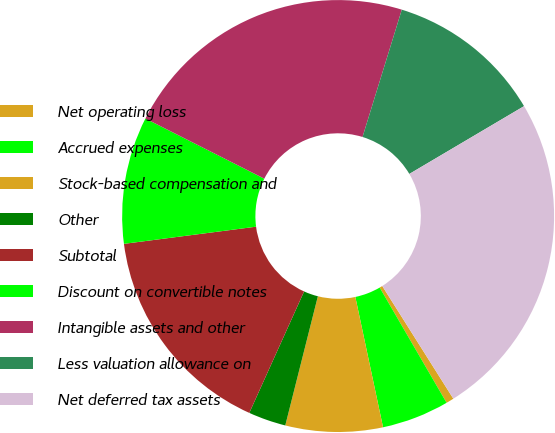Convert chart to OTSL. <chart><loc_0><loc_0><loc_500><loc_500><pie_chart><fcel>Net operating loss<fcel>Accrued expenses<fcel>Stock-based compensation and<fcel>Other<fcel>Subtotal<fcel>Discount on convertible notes<fcel>Intangible assets and other<fcel>Less valuation allowance on<fcel>Net deferred tax assets<nl><fcel>0.58%<fcel>5.04%<fcel>7.27%<fcel>2.81%<fcel>16.2%<fcel>9.51%<fcel>22.31%<fcel>11.74%<fcel>24.54%<nl></chart> 